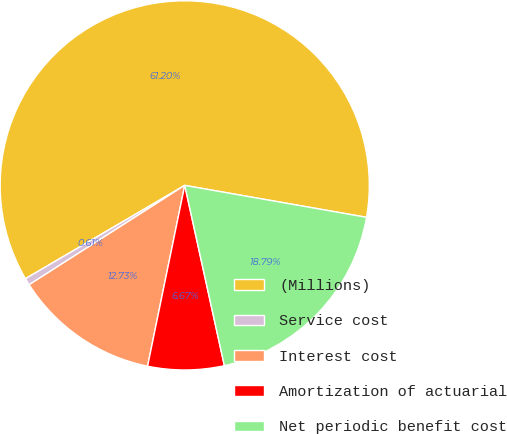Convert chart. <chart><loc_0><loc_0><loc_500><loc_500><pie_chart><fcel>(Millions)<fcel>Service cost<fcel>Interest cost<fcel>Amortization of actuarial<fcel>Net periodic benefit cost<nl><fcel>61.21%<fcel>0.61%<fcel>12.73%<fcel>6.67%<fcel>18.79%<nl></chart> 